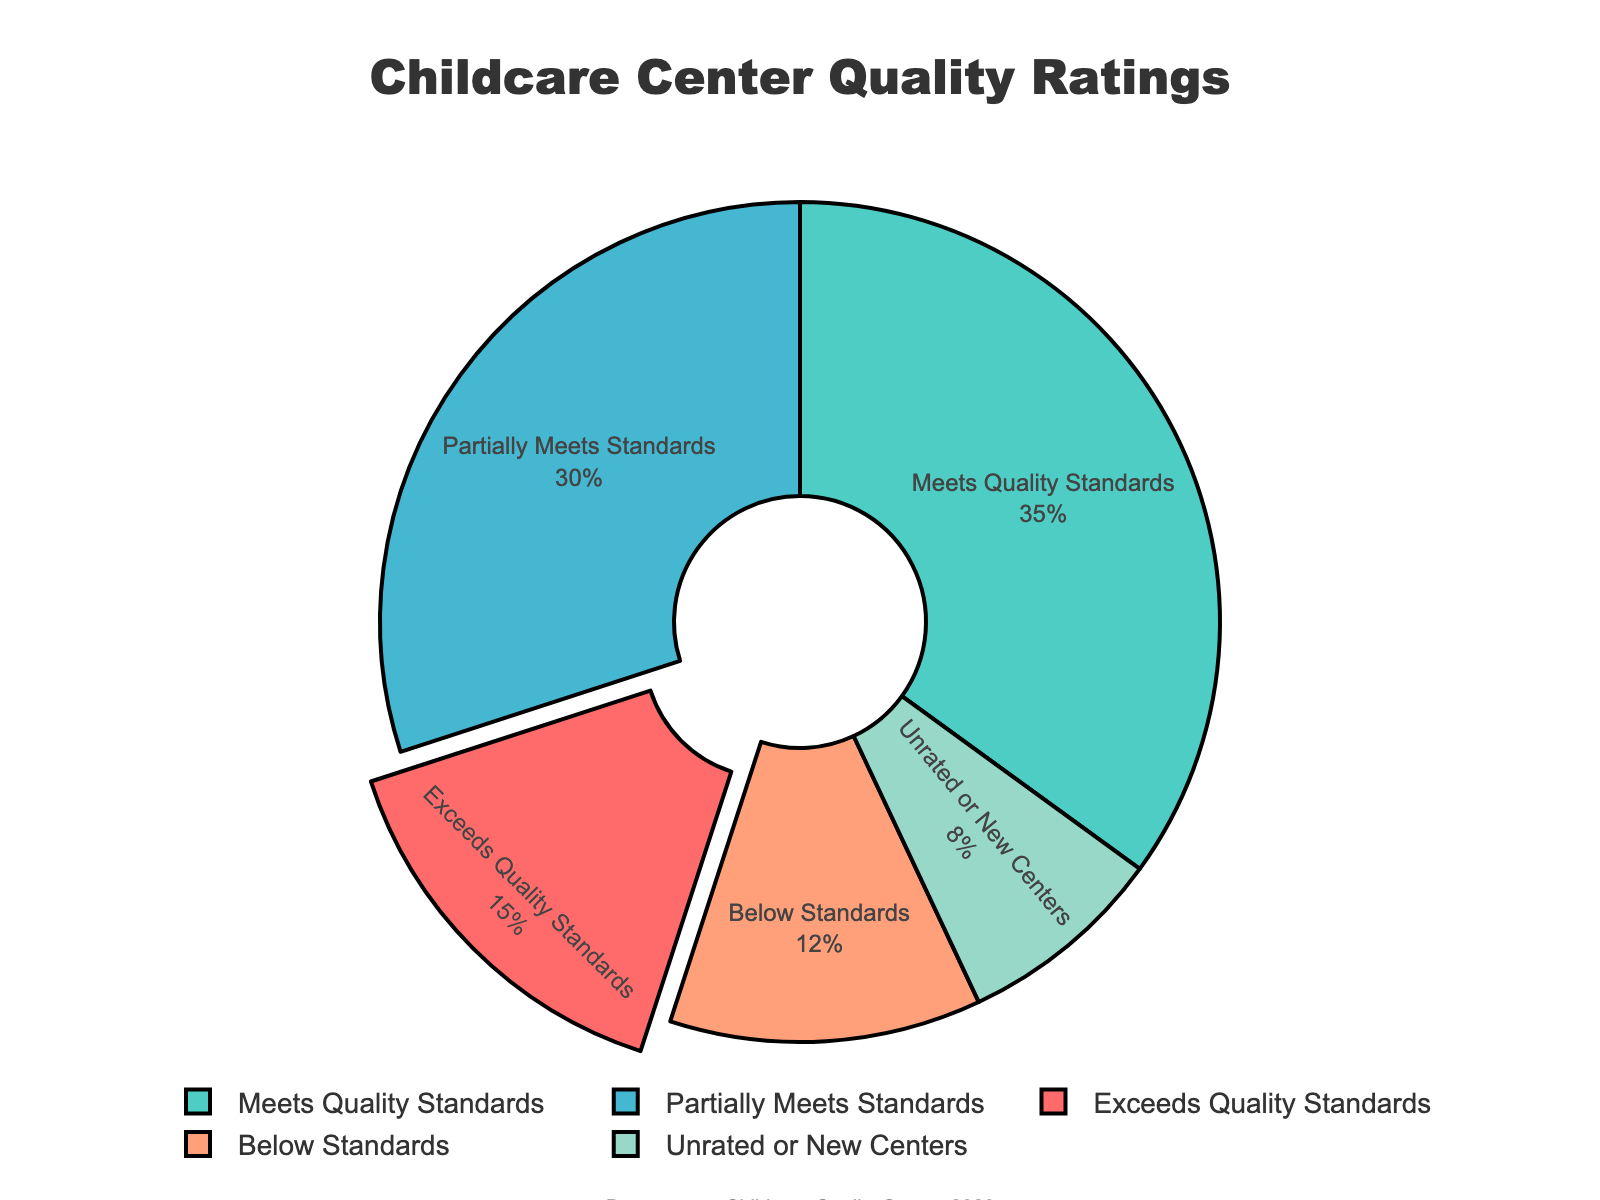what proportion of childcare centers meet or exceed quality standards? The pie chart shows percentages for different quality ratings. To find the combined percentage of centers that meet or exceed standards, sum the percentages of "Meets Quality Standards" (35) and "Exceeds Quality Standards" (15). Adding these gives 35 + 15 = 50%.
Answer: 50% What is the percentage difference between centers that meet standards and those that exceed them? The pie chart shows 35% of centers meet standards, and 15% exceed them. To find the difference, subtract the smaller percentage from the larger: 35% - 15% = 20%.
Answer: 20% Which category has the smallest proportion of childcare centers? Look at the pie chart to identify the segment with the smallest percentage. "Unrated or New Centers" has the smallest proportion at 8%.
Answer: Unrated or New Centers Are there more centers that partially meet standards compared to those that are below standards? Compare the percentages of "Partially Meets Standards" and "Below Standards." "Partially Meets Standards" is 30%, and "Below Standards" is 12%. Since 30% is greater than 12%, there are more centers that partially meet standards.
Answer: Yes What proportion of childcare centers meet quality standards but not exceed them? The pie chart shows that 35% of centers meet quality standards and do not exceed them.
Answer: 35% How many times greater is the proportion of centers that meet standards than those that are unrated or new? To determine this, divide the percentage of centers that meet standards (35%) by the percentage of unrated or new centers (8%): 35 ÷ 8 ≈ 4.375.
Answer: Approximately 4.38 times Which color represents the category with the proportion of 12%? The pie chart uses colors to differentiate between categories. The segment corresponding to "Below Standards" (12%) is visually represented by one of the colors. From the segment, "Below Standards" is the one in light orange.
Answer: Light orange Is the combined proportion of centers that fail to meet quality standards (below standard and partially meet) greater than the proportion of those that exceed them? Add the percentages of centers that "Partially Meet Standards" (30%) and "Below Standards" (12%): 30 + 12 = 42%. Compare this to the percentage that "Exceeds Quality Standards" (15%). 42% is greater than 15%, so the combined proportion is indeed greater.
Answer: Yes If you randomly pick a childcare center, is it more likely to meet standards or fall below them (either partially or fully)? Combine the percentages of centers that "Partially Meet Standards" and "Below Standards" to determine the likelihood of them not meeting standards: 30% + 12% = 42%. Compare this to the 35% of centers that meet standards. Since 42% is greater than 35%, it is more likely to fall below standards.
Answer: More likely to fall below standards 